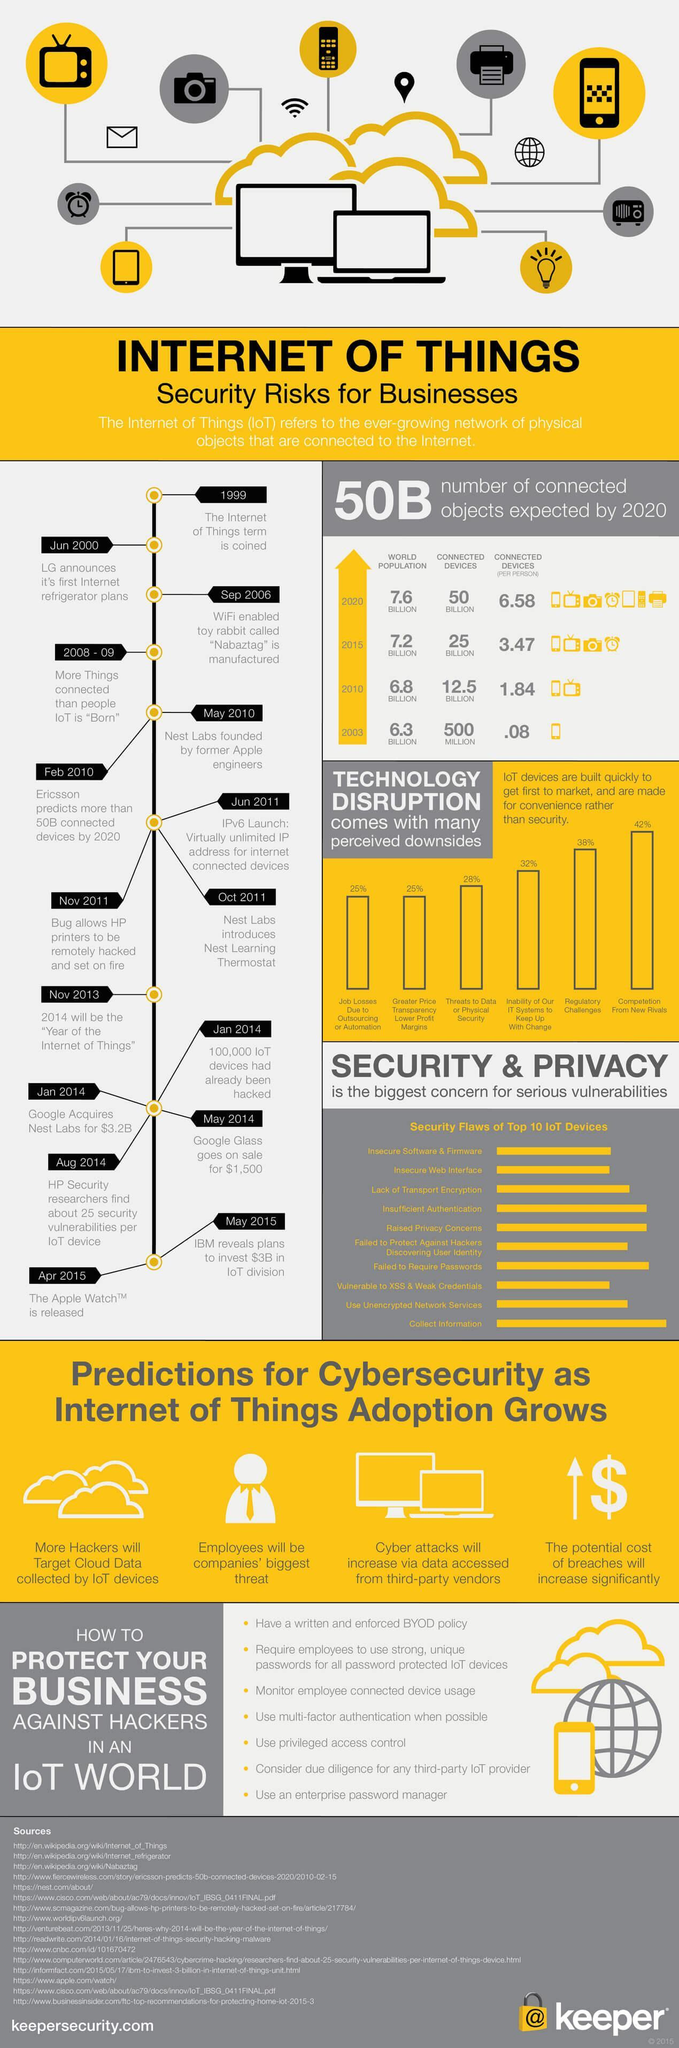What is the biggest challenge in technology disruption?
Answer the question with a short phrase. Competition From New Rivals How many sources are listed? 16 